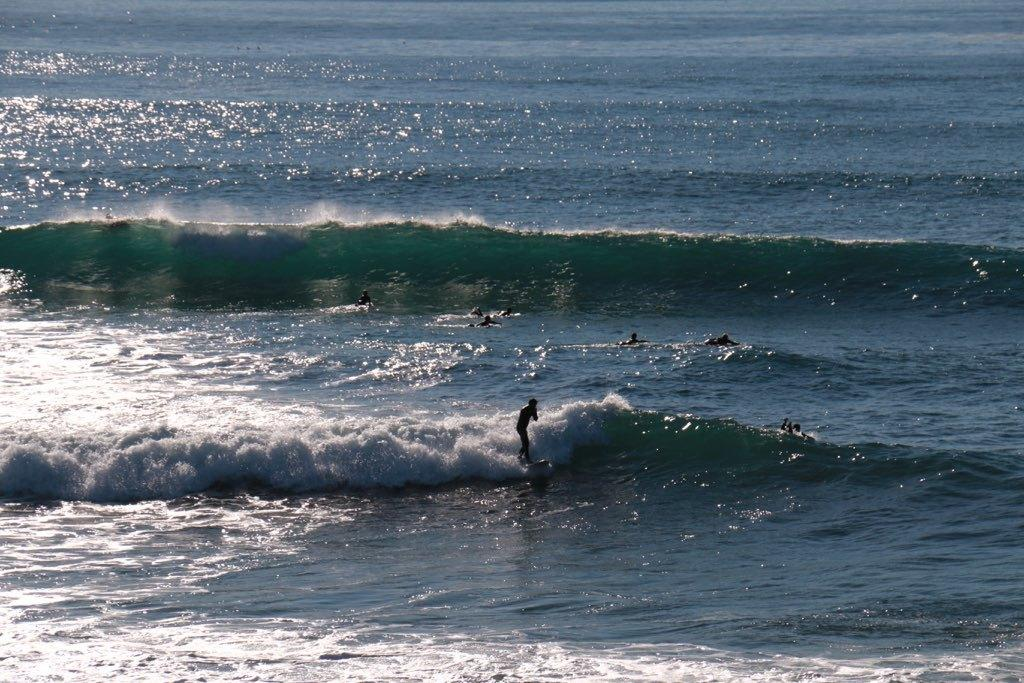What are the people in the image doing? The people in the image are in the water. What can be seen in the background of the image? There is an ocean in the background of the image. What is a natural phenomenon visible in the image? Ocean tides are visible in the image. What type of quilt is being used to keep the people warm in the image? There is no quilt present in the image; the people are in the water. What sound can be heard coming from the alarm in the image? There is no alarm present in the image. 